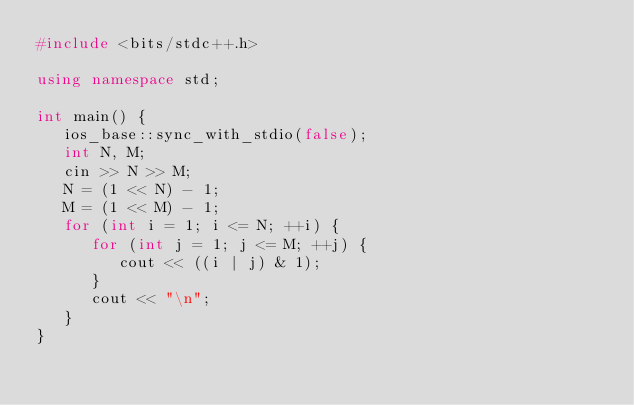<code> <loc_0><loc_0><loc_500><loc_500><_C++_>#include <bits/stdc++.h>

using namespace std;

int main() {
   ios_base::sync_with_stdio(false);
   int N, M;
   cin >> N >> M;
   N = (1 << N) - 1;
   M = (1 << M) - 1;
   for (int i = 1; i <= N; ++i) {
      for (int j = 1; j <= M; ++j) {
         cout << ((i | j) & 1);
      }
      cout << "\n";
   }
}
</code> 